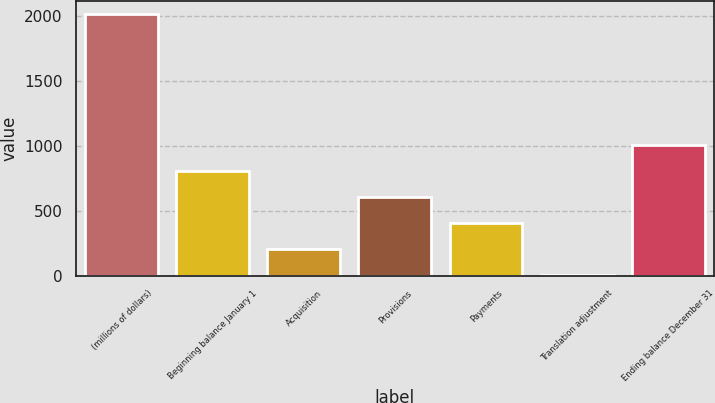Convert chart. <chart><loc_0><loc_0><loc_500><loc_500><bar_chart><fcel>(millions of dollars)<fcel>Beginning balance January 1<fcel>Acquisition<fcel>Provisions<fcel>Payments<fcel>Translation adjustment<fcel>Ending balance December 31<nl><fcel>2011<fcel>805.96<fcel>203.44<fcel>605.12<fcel>404.28<fcel>2.6<fcel>1006.8<nl></chart> 